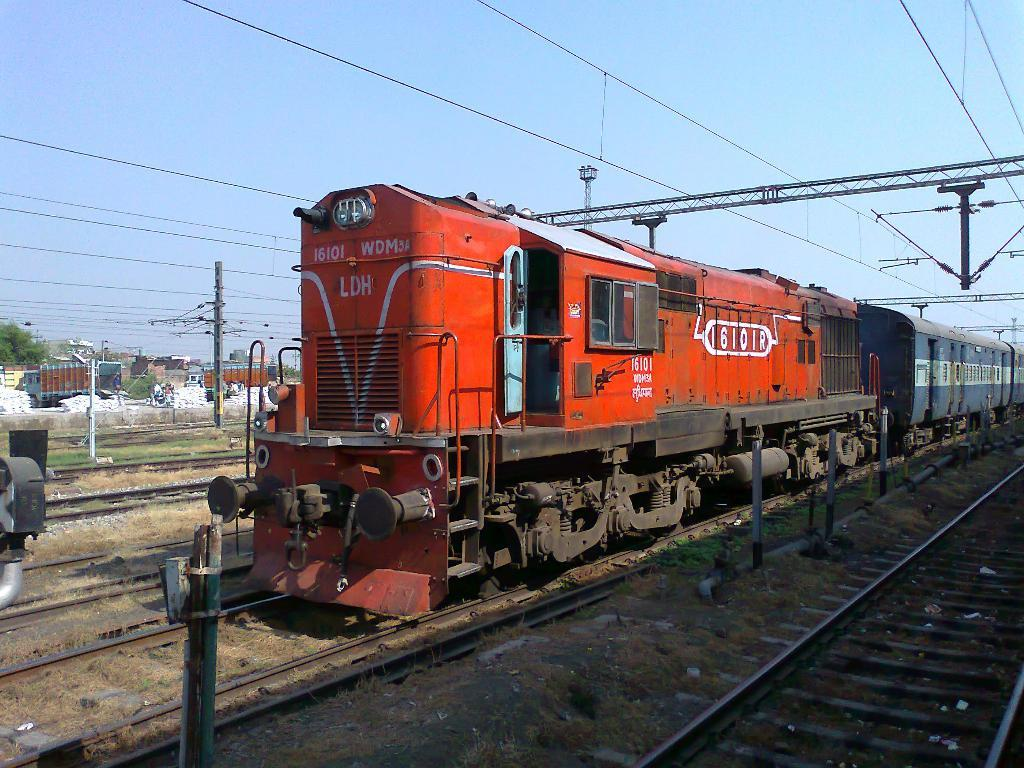<image>
Give a short and clear explanation of the subsequent image. A red train says 16101 WDM LDH on the front and power lines are above the tracks. 